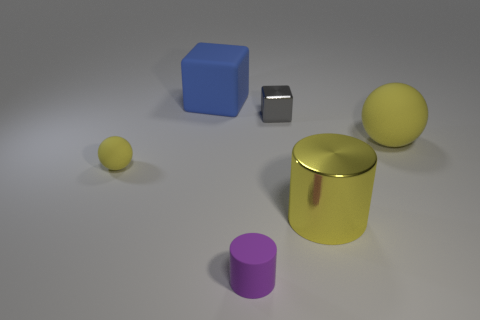Does the cylinder that is behind the purple matte cylinder have the same color as the big matte sphere? yes 